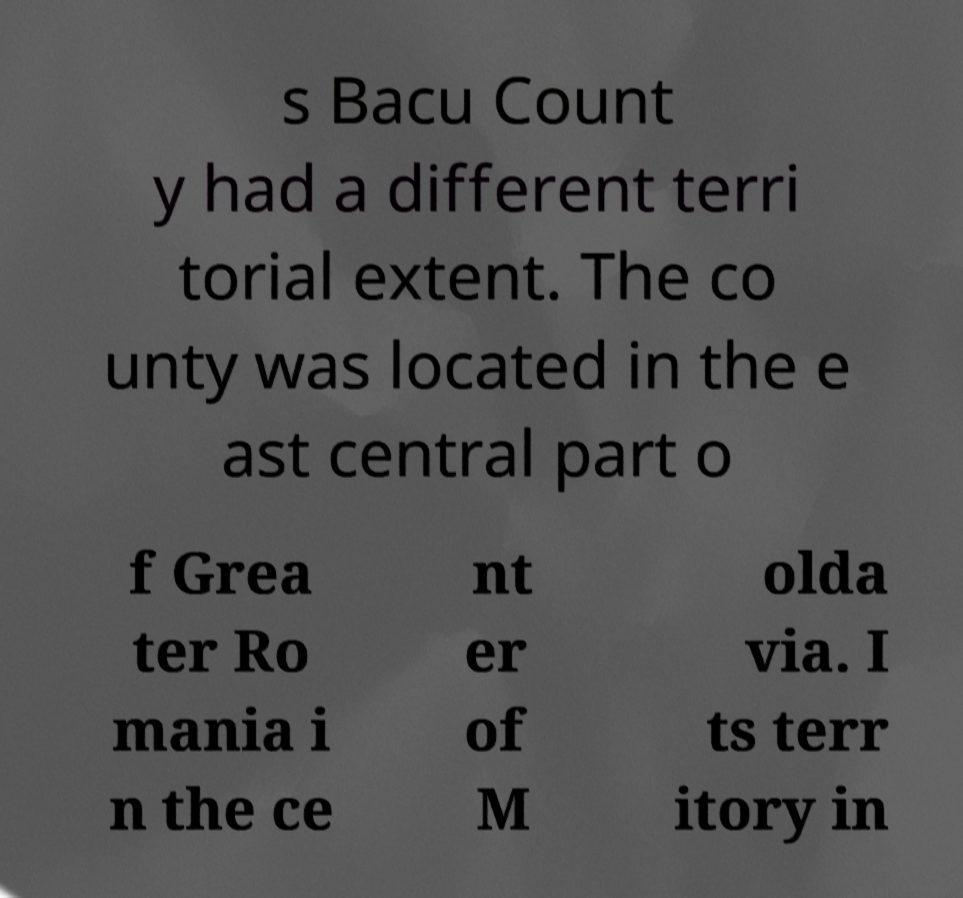For documentation purposes, I need the text within this image transcribed. Could you provide that? s Bacu Count y had a different terri torial extent. The co unty was located in the e ast central part o f Grea ter Ro mania i n the ce nt er of M olda via. I ts terr itory in 